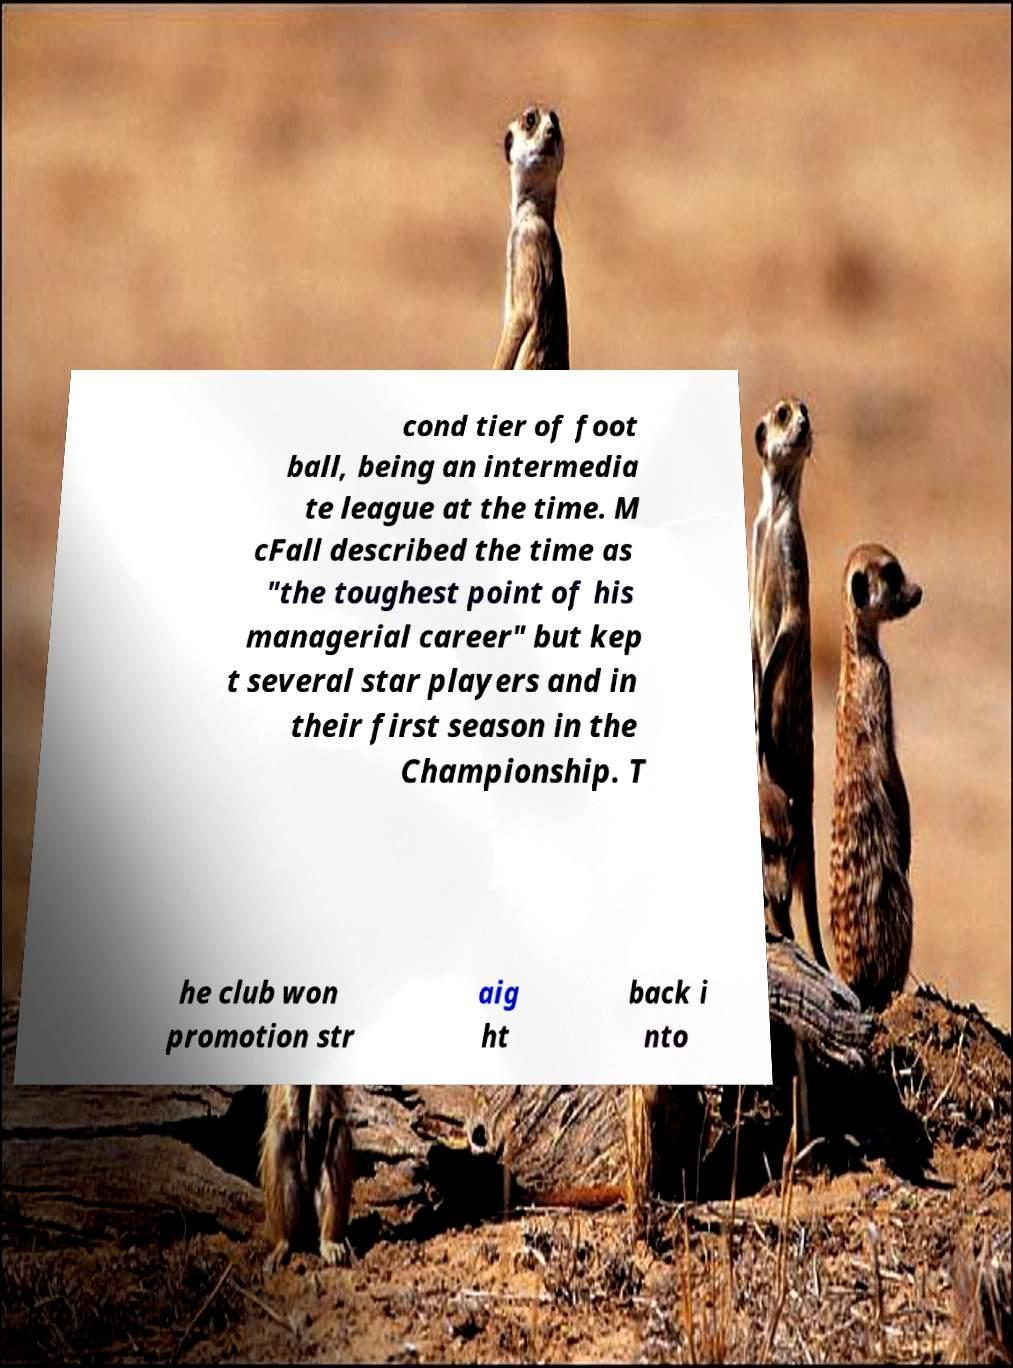For documentation purposes, I need the text within this image transcribed. Could you provide that? cond tier of foot ball, being an intermedia te league at the time. M cFall described the time as "the toughest point of his managerial career" but kep t several star players and in their first season in the Championship. T he club won promotion str aig ht back i nto 